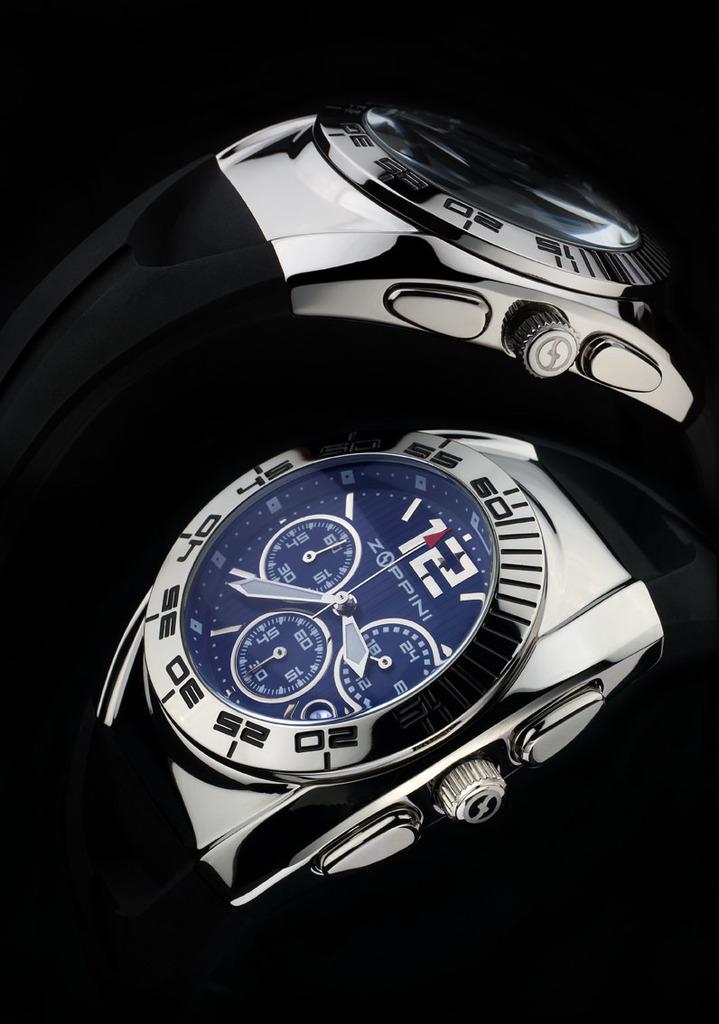What is the brand of watch?
Your answer should be very brief. Zoppini. 